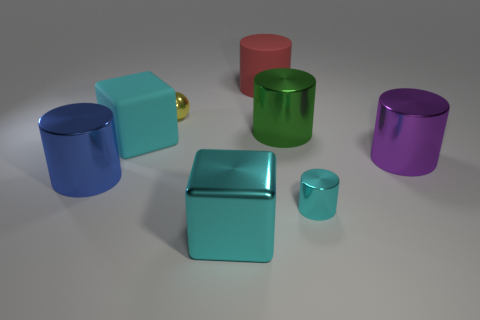Do the metallic cube and the rubber block have the same color?
Provide a succinct answer. Yes. There is a big metal block; are there any big objects right of it?
Give a very brief answer. Yes. There is a green object; is it the same size as the cyan object right of the big red matte thing?
Make the answer very short. No. What is the color of the big shiny thing right of the small shiny thing that is right of the metal sphere?
Offer a terse response. Purple. Does the red matte object have the same size as the yellow ball?
Give a very brief answer. No. There is a cylinder that is behind the big rubber block and in front of the yellow ball; what color is it?
Your answer should be very brief. Green. What is the size of the yellow metal object?
Offer a very short reply. Small. There is a matte thing in front of the big green thing; is its color the same as the big shiny cube?
Your response must be concise. Yes. Is the number of objects that are on the right side of the blue metallic cylinder greater than the number of metal spheres that are behind the small yellow shiny object?
Provide a succinct answer. Yes. Is the number of cyan metal blocks greater than the number of large brown shiny balls?
Keep it short and to the point. Yes. 